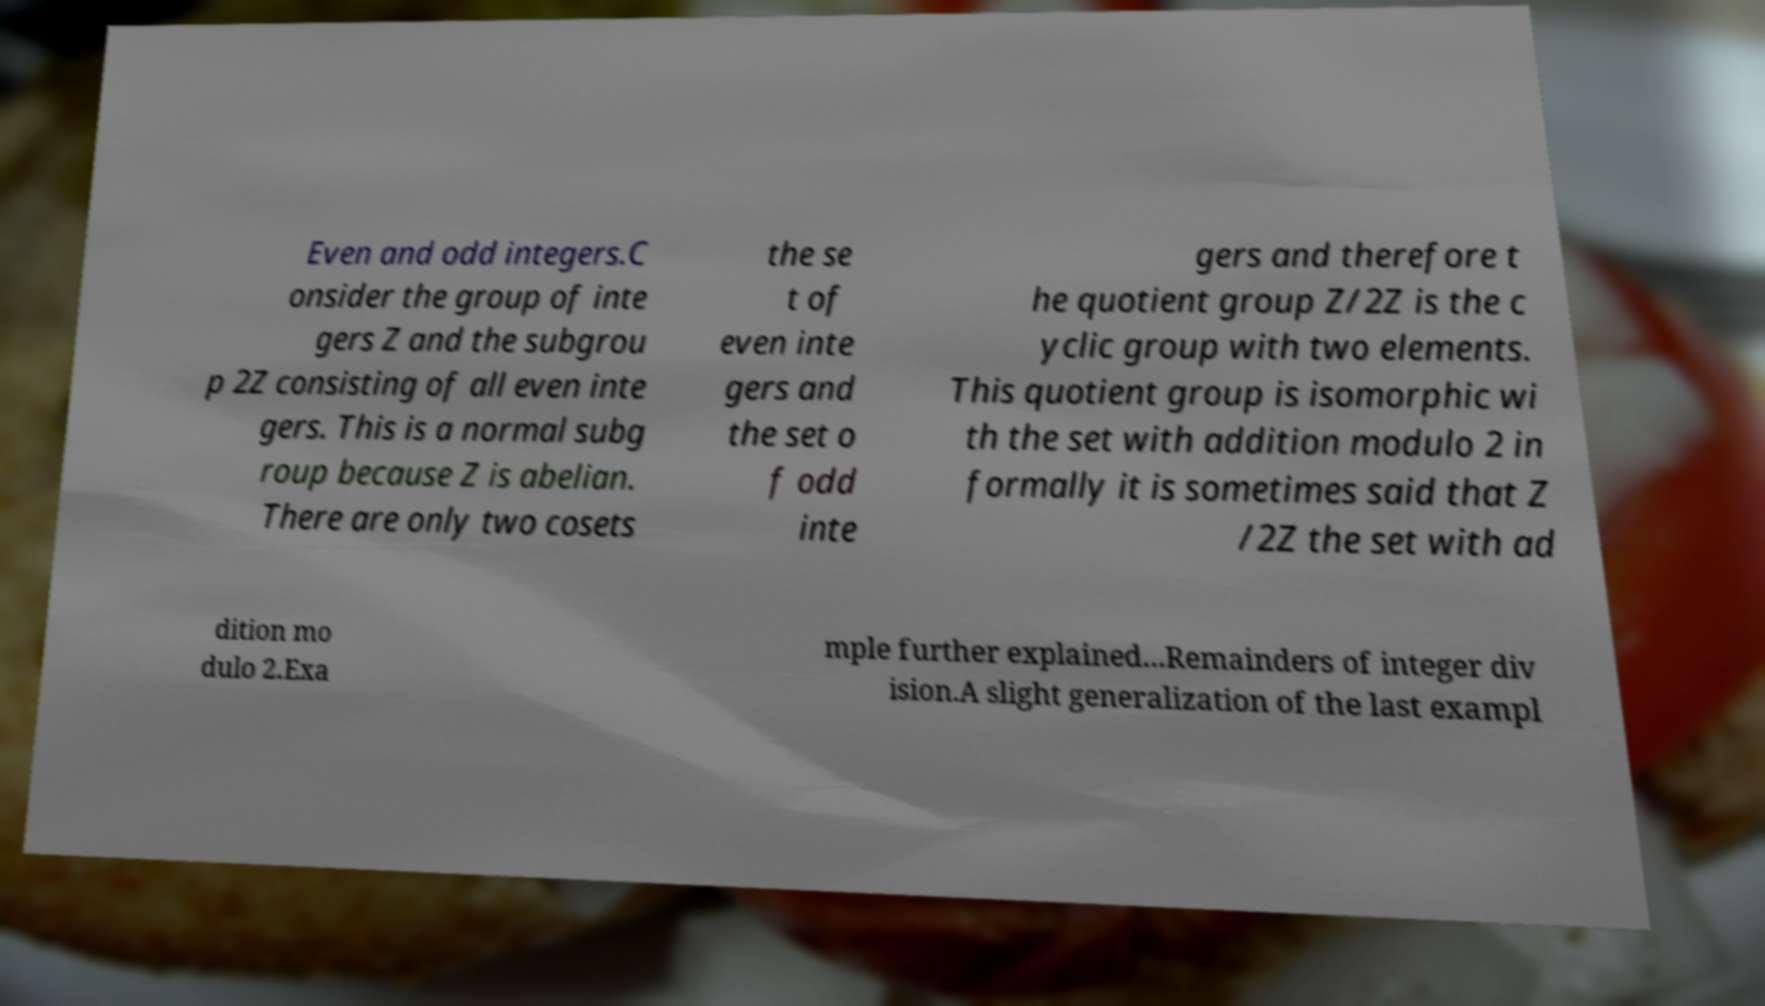Could you extract and type out the text from this image? Even and odd integers.C onsider the group of inte gers Z and the subgrou p 2Z consisting of all even inte gers. This is a normal subg roup because Z is abelian. There are only two cosets the se t of even inte gers and the set o f odd inte gers and therefore t he quotient group Z/2Z is the c yclic group with two elements. This quotient group is isomorphic wi th the set with addition modulo 2 in formally it is sometimes said that Z /2Z the set with ad dition mo dulo 2.Exa mple further explained...Remainders of integer div ision.A slight generalization of the last exampl 